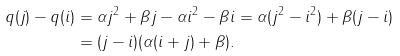<formula> <loc_0><loc_0><loc_500><loc_500>q ( j ) - q ( i ) & = \alpha j ^ { 2 } + \beta j - \alpha i ^ { 2 } - \beta i = \alpha ( j ^ { 2 } - i ^ { 2 } ) + \beta ( j - i ) \\ & = ( j - i ) ( \alpha ( i + j ) + \beta ) .</formula> 